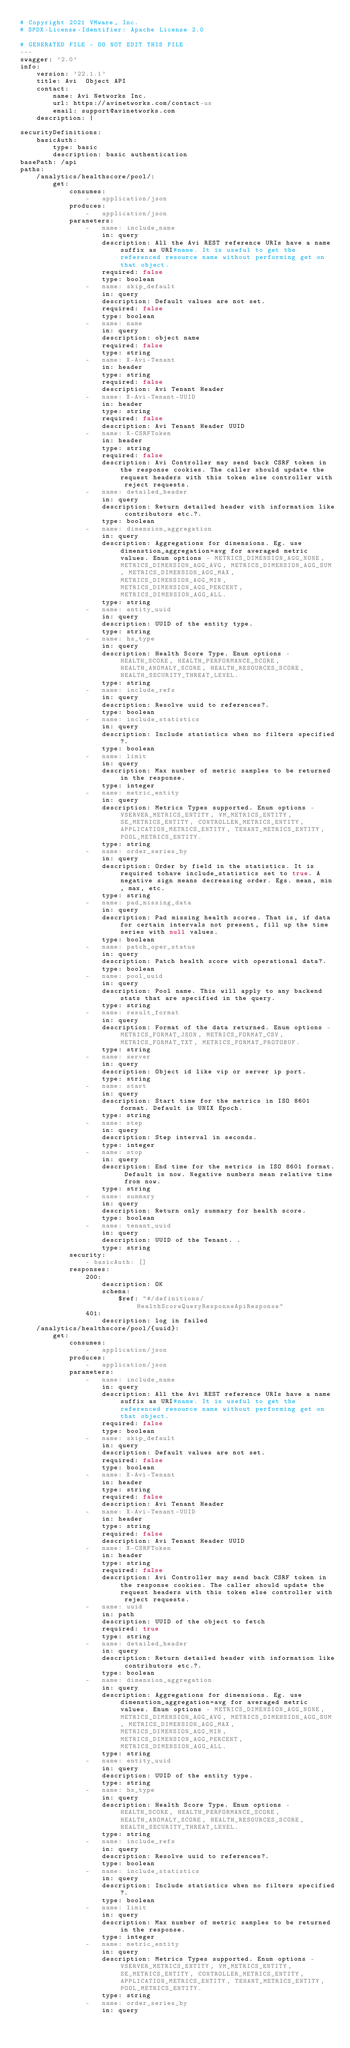Convert code to text. <code><loc_0><loc_0><loc_500><loc_500><_YAML_># Copyright 2021 VMware, Inc.
# SPDX-License-Identifier: Apache License 2.0

# GENERATED FILE - DO NOT EDIT THIS FILE
---
swagger: '2.0'
info:
    version: '22.1.1'
    title: Avi  Object API
    contact:
        name: Avi Networks Inc.
        url: https://avinetworks.com/contact-us
        email: support@avinetworks.com
    description: |

securityDefinitions:
    basicAuth:
        type: basic
        description: basic authentication
basePath: /api
paths:
    /analytics/healthscore/pool/:
        get:
            consumes:
                -   application/json
            produces:
                -   application/json
            parameters:
                -   name: include_name
                    in: query
                    description: All the Avi REST reference URIs have a name suffix as URI#name. It is useful to get the referenced resource name without performing get on that object.
                    required: false
                    type: boolean
                -   name: skip_default
                    in: query
                    description: Default values are not set.
                    required: false
                    type: boolean
                -   name: name
                    in: query
                    description: object name
                    required: false
                    type: string
                -   name: X-Avi-Tenant
                    in: header
                    type: string
                    required: false
                    description: Avi Tenant Header
                -   name: X-Avi-Tenant-UUID
                    in: header
                    type: string
                    required: false
                    description: Avi Tenant Header UUID
                -   name: X-CSRFToken
                    in: header
                    type: string
                    required: false
                    description: Avi Controller may send back CSRF token in the response cookies. The caller should update the request headers with this token else controller with reject requests.
                -   name: detailed_header
                    in: query
                    description: Return detailed header with information like contributors etc.?.
                    type: boolean
                -   name: dimension_aggregation
                    in: query
                    description: Aggregations for dimensions. Eg. use dimenstion_aggregation=avg for averaged metric values. Enum options - METRICS_DIMENSION_AGG_NONE, METRICS_DIMENSION_AGG_AVG, METRICS_DIMENSION_AGG_SUM, METRICS_DIMENSION_AGG_MAX, METRICS_DIMENSION_AGG_MIN, METRICS_DIMENSION_AGG_PERCENT, METRICS_DIMENSION_AGG_ALL.
                    type: string
                -   name: entity_uuid
                    in: query
                    description: UUID of the entity type.
                    type: string
                -   name: hs_type
                    in: query
                    description: Health Score Type. Enum options - HEALTH_SCORE, HEALTH_PERFORMANCE_SCORE, HEALTH_ANOMALY_SCORE, HEALTH_RESOURCES_SCORE, HEALTH_SECURITY_THREAT_LEVEL.
                    type: string
                -   name: include_refs
                    in: query
                    description: Resolve uuid to references?.
                    type: boolean
                -   name: include_statistics
                    in: query
                    description: Include statistics when no filters specified?.
                    type: boolean
                -   name: limit
                    in: query
                    description: Max number of metric samples to be returned in the response.
                    type: integer
                -   name: metric_entity
                    in: query
                    description: Metrics Types supported. Enum options - VSERVER_METRICS_ENTITY, VM_METRICS_ENTITY, SE_METRICS_ENTITY, CONTROLLER_METRICS_ENTITY, APPLICATION_METRICS_ENTITY, TENANT_METRICS_ENTITY, POOL_METRICS_ENTITY.
                    type: string
                -   name: order_series_by
                    in: query
                    description: Order by field in the statistics. It is required tohave include_statistics set to true. A negative sign means decreasing order. Egs. mean, min, max, etc.
                    type: string
                -   name: pad_missing_data
                    in: query
                    description: Pad missing health scores. That is, if data for certain intervals not present, fill up the time series with null values.
                    type: boolean
                -   name: patch_oper_status
                    in: query
                    description: Patch health score with operational data?.
                    type: boolean
                -   name: pool_uuid
                    in: query
                    description: Pool name. This will apply to any backend stats that are specified in the query.
                    type: string
                -   name: result_format
                    in: query
                    description: Format of the data returned. Enum options - METRICS_FORMAT_JSON, METRICS_FORMAT_CSV, METRICS_FORMAT_TXT, METRICS_FORMAT_PROTOBUF.
                    type: string
                -   name: server
                    in: query
                    description: Object id like vip or server ip port.
                    type: string
                -   name: start
                    in: query
                    description: Start time for the metrics in ISO 8601 format. Default is UNIX Epoch.
                    type: string
                -   name: step
                    in: query
                    description: Step interval in seconds.
                    type: integer
                -   name: stop
                    in: query
                    description: End time for the metrics in ISO 8601 format. Default is now. Negative numbers mean relative time from now.
                    type: string
                -   name: summary
                    in: query
                    description: Return only summary for health score.
                    type: boolean
                -   name: tenant_uuid
                    in: query
                    description: UUID of the Tenant. .
                    type: string
            security:
                - basicAuth: []
            responses:
                200:
                    description: OK
                    schema:
                        $ref: "#/definitions/HealthScoreQueryResponseApiResponse"
                401:
                    description: log in failed
    /analytics/healthscore/pool/{uuid}:
        get:
            consumes:
                -   application/json
            produces:
                -   application/json
            parameters:
                -   name: include_name
                    in: query
                    description: All the Avi REST reference URIs have a name suffix as URI#name. It is useful to get the referenced resource name without performing get on that object.
                    required: false
                    type: boolean
                -   name: skip_default
                    in: query
                    description: Default values are not set.
                    required: false
                    type: boolean
                -   name: X-Avi-Tenant
                    in: header
                    type: string
                    required: false
                    description: Avi Tenant Header
                -   name: X-Avi-Tenant-UUID
                    in: header
                    type: string
                    required: false
                    description: Avi Tenant Header UUID
                -   name: X-CSRFToken
                    in: header
                    type: string
                    required: false
                    description: Avi Controller may send back CSRF token in the response cookies. The caller should update the request headers with this token else controller with reject requests.
                -   name: uuid
                    in: path
                    description: UUID of the object to fetch
                    required: true
                    type: string
                -   name: detailed_header
                    in: query
                    description: Return detailed header with information like contributors etc.?.
                    type: boolean
                -   name: dimension_aggregation
                    in: query
                    description: Aggregations for dimensions. Eg. use dimenstion_aggregation=avg for averaged metric values. Enum options - METRICS_DIMENSION_AGG_NONE, METRICS_DIMENSION_AGG_AVG, METRICS_DIMENSION_AGG_SUM, METRICS_DIMENSION_AGG_MAX, METRICS_DIMENSION_AGG_MIN, METRICS_DIMENSION_AGG_PERCENT, METRICS_DIMENSION_AGG_ALL.
                    type: string
                -   name: entity_uuid
                    in: query
                    description: UUID of the entity type.
                    type: string
                -   name: hs_type
                    in: query
                    description: Health Score Type. Enum options - HEALTH_SCORE, HEALTH_PERFORMANCE_SCORE, HEALTH_ANOMALY_SCORE, HEALTH_RESOURCES_SCORE, HEALTH_SECURITY_THREAT_LEVEL.
                    type: string
                -   name: include_refs
                    in: query
                    description: Resolve uuid to references?.
                    type: boolean
                -   name: include_statistics
                    in: query
                    description: Include statistics when no filters specified?.
                    type: boolean
                -   name: limit
                    in: query
                    description: Max number of metric samples to be returned in the response.
                    type: integer
                -   name: metric_entity
                    in: query
                    description: Metrics Types supported. Enum options - VSERVER_METRICS_ENTITY, VM_METRICS_ENTITY, SE_METRICS_ENTITY, CONTROLLER_METRICS_ENTITY, APPLICATION_METRICS_ENTITY, TENANT_METRICS_ENTITY, POOL_METRICS_ENTITY.
                    type: string
                -   name: order_series_by
                    in: query</code> 